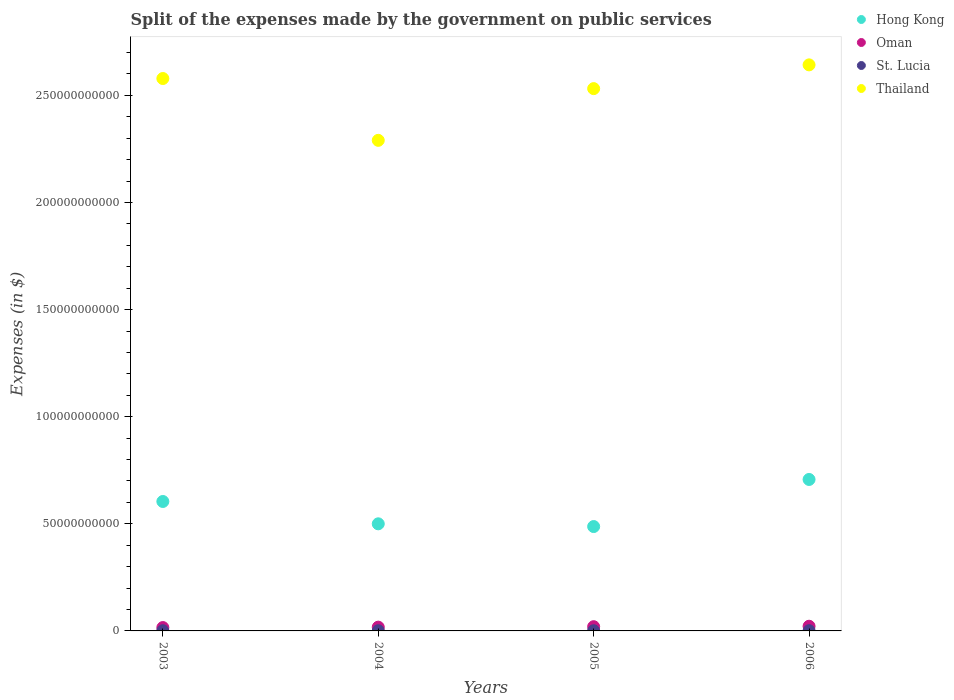What is the expenses made by the government on public services in Oman in 2004?
Provide a short and direct response. 1.77e+09. Across all years, what is the maximum expenses made by the government on public services in Oman?
Offer a very short reply. 2.18e+09. Across all years, what is the minimum expenses made by the government on public services in St. Lucia?
Provide a succinct answer. 8.95e+07. In which year was the expenses made by the government on public services in Thailand maximum?
Give a very brief answer. 2006. In which year was the expenses made by the government on public services in Thailand minimum?
Provide a succinct answer. 2004. What is the total expenses made by the government on public services in Oman in the graph?
Provide a succinct answer. 7.50e+09. What is the difference between the expenses made by the government on public services in Hong Kong in 2005 and that in 2006?
Ensure brevity in your answer.  -2.20e+1. What is the difference between the expenses made by the government on public services in Oman in 2003 and the expenses made by the government on public services in Hong Kong in 2005?
Ensure brevity in your answer.  -4.71e+1. What is the average expenses made by the government on public services in Thailand per year?
Ensure brevity in your answer.  2.51e+11. In the year 2006, what is the difference between the expenses made by the government on public services in St. Lucia and expenses made by the government on public services in Thailand?
Keep it short and to the point. -2.64e+11. In how many years, is the expenses made by the government on public services in Hong Kong greater than 230000000000 $?
Offer a very short reply. 0. What is the ratio of the expenses made by the government on public services in Thailand in 2003 to that in 2006?
Your answer should be very brief. 0.98. Is the expenses made by the government on public services in Hong Kong in 2003 less than that in 2006?
Provide a short and direct response. Yes. What is the difference between the highest and the second highest expenses made by the government on public services in Thailand?
Offer a terse response. 6.37e+09. What is the difference between the highest and the lowest expenses made by the government on public services in Hong Kong?
Offer a terse response. 2.20e+1. Is it the case that in every year, the sum of the expenses made by the government on public services in Oman and expenses made by the government on public services in St. Lucia  is greater than the expenses made by the government on public services in Hong Kong?
Provide a succinct answer. No. Does the expenses made by the government on public services in Oman monotonically increase over the years?
Offer a very short reply. Yes. Is the expenses made by the government on public services in Thailand strictly greater than the expenses made by the government on public services in Hong Kong over the years?
Give a very brief answer. Yes. Is the expenses made by the government on public services in Hong Kong strictly less than the expenses made by the government on public services in Oman over the years?
Make the answer very short. No. Are the values on the major ticks of Y-axis written in scientific E-notation?
Offer a very short reply. No. Does the graph contain any zero values?
Give a very brief answer. No. Does the graph contain grids?
Ensure brevity in your answer.  No. Where does the legend appear in the graph?
Your answer should be compact. Top right. How are the legend labels stacked?
Your answer should be compact. Vertical. What is the title of the graph?
Your answer should be compact. Split of the expenses made by the government on public services. What is the label or title of the X-axis?
Offer a very short reply. Years. What is the label or title of the Y-axis?
Provide a succinct answer. Expenses (in $). What is the Expenses (in $) in Hong Kong in 2003?
Offer a very short reply. 6.04e+1. What is the Expenses (in $) in Oman in 2003?
Provide a succinct answer. 1.57e+09. What is the Expenses (in $) in St. Lucia in 2003?
Give a very brief answer. 8.95e+07. What is the Expenses (in $) of Thailand in 2003?
Offer a terse response. 2.58e+11. What is the Expenses (in $) in Hong Kong in 2004?
Keep it short and to the point. 5.00e+1. What is the Expenses (in $) of Oman in 2004?
Keep it short and to the point. 1.77e+09. What is the Expenses (in $) in St. Lucia in 2004?
Ensure brevity in your answer.  9.55e+07. What is the Expenses (in $) in Thailand in 2004?
Make the answer very short. 2.29e+11. What is the Expenses (in $) in Hong Kong in 2005?
Give a very brief answer. 4.87e+1. What is the Expenses (in $) of Oman in 2005?
Your answer should be compact. 1.97e+09. What is the Expenses (in $) in St. Lucia in 2005?
Offer a very short reply. 9.10e+07. What is the Expenses (in $) of Thailand in 2005?
Your response must be concise. 2.53e+11. What is the Expenses (in $) in Hong Kong in 2006?
Keep it short and to the point. 7.07e+1. What is the Expenses (in $) of Oman in 2006?
Your answer should be compact. 2.18e+09. What is the Expenses (in $) in St. Lucia in 2006?
Ensure brevity in your answer.  1.04e+08. What is the Expenses (in $) in Thailand in 2006?
Your response must be concise. 2.64e+11. Across all years, what is the maximum Expenses (in $) of Hong Kong?
Offer a terse response. 7.07e+1. Across all years, what is the maximum Expenses (in $) in Oman?
Offer a very short reply. 2.18e+09. Across all years, what is the maximum Expenses (in $) in St. Lucia?
Provide a succinct answer. 1.04e+08. Across all years, what is the maximum Expenses (in $) in Thailand?
Ensure brevity in your answer.  2.64e+11. Across all years, what is the minimum Expenses (in $) of Hong Kong?
Provide a succinct answer. 4.87e+1. Across all years, what is the minimum Expenses (in $) in Oman?
Provide a short and direct response. 1.57e+09. Across all years, what is the minimum Expenses (in $) in St. Lucia?
Your response must be concise. 8.95e+07. Across all years, what is the minimum Expenses (in $) in Thailand?
Your response must be concise. 2.29e+11. What is the total Expenses (in $) of Hong Kong in the graph?
Provide a short and direct response. 2.30e+11. What is the total Expenses (in $) in Oman in the graph?
Your response must be concise. 7.50e+09. What is the total Expenses (in $) of St. Lucia in the graph?
Your answer should be very brief. 3.80e+08. What is the total Expenses (in $) of Thailand in the graph?
Make the answer very short. 1.00e+12. What is the difference between the Expenses (in $) of Hong Kong in 2003 and that in 2004?
Keep it short and to the point. 1.04e+1. What is the difference between the Expenses (in $) in Oman in 2003 and that in 2004?
Your answer should be very brief. -1.93e+08. What is the difference between the Expenses (in $) in St. Lucia in 2003 and that in 2004?
Give a very brief answer. -6.00e+06. What is the difference between the Expenses (in $) in Thailand in 2003 and that in 2004?
Give a very brief answer. 2.89e+1. What is the difference between the Expenses (in $) of Hong Kong in 2003 and that in 2005?
Your answer should be compact. 1.17e+1. What is the difference between the Expenses (in $) in Oman in 2003 and that in 2005?
Offer a terse response. -3.99e+08. What is the difference between the Expenses (in $) in St. Lucia in 2003 and that in 2005?
Your response must be concise. -1.50e+06. What is the difference between the Expenses (in $) in Thailand in 2003 and that in 2005?
Provide a short and direct response. 4.71e+09. What is the difference between the Expenses (in $) of Hong Kong in 2003 and that in 2006?
Provide a succinct answer. -1.03e+1. What is the difference between the Expenses (in $) in Oman in 2003 and that in 2006?
Your response must be concise. -6.12e+08. What is the difference between the Expenses (in $) of St. Lucia in 2003 and that in 2006?
Your answer should be very brief. -1.48e+07. What is the difference between the Expenses (in $) in Thailand in 2003 and that in 2006?
Your answer should be compact. -6.37e+09. What is the difference between the Expenses (in $) in Hong Kong in 2004 and that in 2005?
Make the answer very short. 1.28e+09. What is the difference between the Expenses (in $) in Oman in 2004 and that in 2005?
Provide a succinct answer. -2.07e+08. What is the difference between the Expenses (in $) of St. Lucia in 2004 and that in 2005?
Make the answer very short. 4.50e+06. What is the difference between the Expenses (in $) of Thailand in 2004 and that in 2005?
Ensure brevity in your answer.  -2.41e+1. What is the difference between the Expenses (in $) in Hong Kong in 2004 and that in 2006?
Give a very brief answer. -2.07e+1. What is the difference between the Expenses (in $) in Oman in 2004 and that in 2006?
Your answer should be compact. -4.19e+08. What is the difference between the Expenses (in $) in St. Lucia in 2004 and that in 2006?
Offer a terse response. -8.80e+06. What is the difference between the Expenses (in $) of Thailand in 2004 and that in 2006?
Provide a succinct answer. -3.52e+1. What is the difference between the Expenses (in $) in Hong Kong in 2005 and that in 2006?
Your answer should be very brief. -2.20e+1. What is the difference between the Expenses (in $) in Oman in 2005 and that in 2006?
Your answer should be compact. -2.12e+08. What is the difference between the Expenses (in $) in St. Lucia in 2005 and that in 2006?
Keep it short and to the point. -1.33e+07. What is the difference between the Expenses (in $) of Thailand in 2005 and that in 2006?
Your answer should be compact. -1.11e+1. What is the difference between the Expenses (in $) in Hong Kong in 2003 and the Expenses (in $) in Oman in 2004?
Give a very brief answer. 5.87e+1. What is the difference between the Expenses (in $) in Hong Kong in 2003 and the Expenses (in $) in St. Lucia in 2004?
Offer a very short reply. 6.03e+1. What is the difference between the Expenses (in $) in Hong Kong in 2003 and the Expenses (in $) in Thailand in 2004?
Your response must be concise. -1.69e+11. What is the difference between the Expenses (in $) in Oman in 2003 and the Expenses (in $) in St. Lucia in 2004?
Provide a succinct answer. 1.48e+09. What is the difference between the Expenses (in $) in Oman in 2003 and the Expenses (in $) in Thailand in 2004?
Offer a very short reply. -2.27e+11. What is the difference between the Expenses (in $) in St. Lucia in 2003 and the Expenses (in $) in Thailand in 2004?
Provide a succinct answer. -2.29e+11. What is the difference between the Expenses (in $) in Hong Kong in 2003 and the Expenses (in $) in Oman in 2005?
Offer a very short reply. 5.84e+1. What is the difference between the Expenses (in $) in Hong Kong in 2003 and the Expenses (in $) in St. Lucia in 2005?
Your response must be concise. 6.03e+1. What is the difference between the Expenses (in $) in Hong Kong in 2003 and the Expenses (in $) in Thailand in 2005?
Provide a short and direct response. -1.93e+11. What is the difference between the Expenses (in $) in Oman in 2003 and the Expenses (in $) in St. Lucia in 2005?
Make the answer very short. 1.48e+09. What is the difference between the Expenses (in $) of Oman in 2003 and the Expenses (in $) of Thailand in 2005?
Your response must be concise. -2.52e+11. What is the difference between the Expenses (in $) in St. Lucia in 2003 and the Expenses (in $) in Thailand in 2005?
Make the answer very short. -2.53e+11. What is the difference between the Expenses (in $) of Hong Kong in 2003 and the Expenses (in $) of Oman in 2006?
Make the answer very short. 5.82e+1. What is the difference between the Expenses (in $) of Hong Kong in 2003 and the Expenses (in $) of St. Lucia in 2006?
Give a very brief answer. 6.03e+1. What is the difference between the Expenses (in $) in Hong Kong in 2003 and the Expenses (in $) in Thailand in 2006?
Your answer should be very brief. -2.04e+11. What is the difference between the Expenses (in $) in Oman in 2003 and the Expenses (in $) in St. Lucia in 2006?
Offer a terse response. 1.47e+09. What is the difference between the Expenses (in $) of Oman in 2003 and the Expenses (in $) of Thailand in 2006?
Your response must be concise. -2.63e+11. What is the difference between the Expenses (in $) in St. Lucia in 2003 and the Expenses (in $) in Thailand in 2006?
Offer a very short reply. -2.64e+11. What is the difference between the Expenses (in $) in Hong Kong in 2004 and the Expenses (in $) in Oman in 2005?
Your response must be concise. 4.80e+1. What is the difference between the Expenses (in $) of Hong Kong in 2004 and the Expenses (in $) of St. Lucia in 2005?
Offer a terse response. 4.99e+1. What is the difference between the Expenses (in $) in Hong Kong in 2004 and the Expenses (in $) in Thailand in 2005?
Offer a terse response. -2.03e+11. What is the difference between the Expenses (in $) in Oman in 2004 and the Expenses (in $) in St. Lucia in 2005?
Provide a succinct answer. 1.67e+09. What is the difference between the Expenses (in $) in Oman in 2004 and the Expenses (in $) in Thailand in 2005?
Keep it short and to the point. -2.51e+11. What is the difference between the Expenses (in $) in St. Lucia in 2004 and the Expenses (in $) in Thailand in 2005?
Your answer should be compact. -2.53e+11. What is the difference between the Expenses (in $) of Hong Kong in 2004 and the Expenses (in $) of Oman in 2006?
Your answer should be compact. 4.78e+1. What is the difference between the Expenses (in $) of Hong Kong in 2004 and the Expenses (in $) of St. Lucia in 2006?
Offer a very short reply. 4.99e+1. What is the difference between the Expenses (in $) of Hong Kong in 2004 and the Expenses (in $) of Thailand in 2006?
Provide a succinct answer. -2.14e+11. What is the difference between the Expenses (in $) in Oman in 2004 and the Expenses (in $) in St. Lucia in 2006?
Your response must be concise. 1.66e+09. What is the difference between the Expenses (in $) in Oman in 2004 and the Expenses (in $) in Thailand in 2006?
Provide a short and direct response. -2.62e+11. What is the difference between the Expenses (in $) of St. Lucia in 2004 and the Expenses (in $) of Thailand in 2006?
Provide a succinct answer. -2.64e+11. What is the difference between the Expenses (in $) in Hong Kong in 2005 and the Expenses (in $) in Oman in 2006?
Ensure brevity in your answer.  4.65e+1. What is the difference between the Expenses (in $) in Hong Kong in 2005 and the Expenses (in $) in St. Lucia in 2006?
Give a very brief answer. 4.86e+1. What is the difference between the Expenses (in $) in Hong Kong in 2005 and the Expenses (in $) in Thailand in 2006?
Provide a succinct answer. -2.16e+11. What is the difference between the Expenses (in $) of Oman in 2005 and the Expenses (in $) of St. Lucia in 2006?
Make the answer very short. 1.87e+09. What is the difference between the Expenses (in $) of Oman in 2005 and the Expenses (in $) of Thailand in 2006?
Offer a terse response. -2.62e+11. What is the difference between the Expenses (in $) in St. Lucia in 2005 and the Expenses (in $) in Thailand in 2006?
Your answer should be compact. -2.64e+11. What is the average Expenses (in $) in Hong Kong per year?
Keep it short and to the point. 5.75e+1. What is the average Expenses (in $) of Oman per year?
Ensure brevity in your answer.  1.87e+09. What is the average Expenses (in $) of St. Lucia per year?
Ensure brevity in your answer.  9.51e+07. What is the average Expenses (in $) in Thailand per year?
Ensure brevity in your answer.  2.51e+11. In the year 2003, what is the difference between the Expenses (in $) of Hong Kong and Expenses (in $) of Oman?
Keep it short and to the point. 5.88e+1. In the year 2003, what is the difference between the Expenses (in $) of Hong Kong and Expenses (in $) of St. Lucia?
Your answer should be very brief. 6.03e+1. In the year 2003, what is the difference between the Expenses (in $) of Hong Kong and Expenses (in $) of Thailand?
Keep it short and to the point. -1.97e+11. In the year 2003, what is the difference between the Expenses (in $) of Oman and Expenses (in $) of St. Lucia?
Your response must be concise. 1.48e+09. In the year 2003, what is the difference between the Expenses (in $) of Oman and Expenses (in $) of Thailand?
Your response must be concise. -2.56e+11. In the year 2003, what is the difference between the Expenses (in $) in St. Lucia and Expenses (in $) in Thailand?
Make the answer very short. -2.58e+11. In the year 2004, what is the difference between the Expenses (in $) of Hong Kong and Expenses (in $) of Oman?
Offer a terse response. 4.82e+1. In the year 2004, what is the difference between the Expenses (in $) in Hong Kong and Expenses (in $) in St. Lucia?
Your answer should be very brief. 4.99e+1. In the year 2004, what is the difference between the Expenses (in $) in Hong Kong and Expenses (in $) in Thailand?
Offer a very short reply. -1.79e+11. In the year 2004, what is the difference between the Expenses (in $) in Oman and Expenses (in $) in St. Lucia?
Your answer should be compact. 1.67e+09. In the year 2004, what is the difference between the Expenses (in $) in Oman and Expenses (in $) in Thailand?
Your answer should be compact. -2.27e+11. In the year 2004, what is the difference between the Expenses (in $) in St. Lucia and Expenses (in $) in Thailand?
Offer a terse response. -2.29e+11. In the year 2005, what is the difference between the Expenses (in $) in Hong Kong and Expenses (in $) in Oman?
Provide a short and direct response. 4.67e+1. In the year 2005, what is the difference between the Expenses (in $) of Hong Kong and Expenses (in $) of St. Lucia?
Offer a terse response. 4.86e+1. In the year 2005, what is the difference between the Expenses (in $) of Hong Kong and Expenses (in $) of Thailand?
Ensure brevity in your answer.  -2.04e+11. In the year 2005, what is the difference between the Expenses (in $) in Oman and Expenses (in $) in St. Lucia?
Offer a terse response. 1.88e+09. In the year 2005, what is the difference between the Expenses (in $) in Oman and Expenses (in $) in Thailand?
Keep it short and to the point. -2.51e+11. In the year 2005, what is the difference between the Expenses (in $) of St. Lucia and Expenses (in $) of Thailand?
Offer a terse response. -2.53e+11. In the year 2006, what is the difference between the Expenses (in $) in Hong Kong and Expenses (in $) in Oman?
Your answer should be compact. 6.85e+1. In the year 2006, what is the difference between the Expenses (in $) in Hong Kong and Expenses (in $) in St. Lucia?
Provide a short and direct response. 7.06e+1. In the year 2006, what is the difference between the Expenses (in $) in Hong Kong and Expenses (in $) in Thailand?
Your answer should be compact. -1.94e+11. In the year 2006, what is the difference between the Expenses (in $) of Oman and Expenses (in $) of St. Lucia?
Keep it short and to the point. 2.08e+09. In the year 2006, what is the difference between the Expenses (in $) of Oman and Expenses (in $) of Thailand?
Provide a short and direct response. -2.62e+11. In the year 2006, what is the difference between the Expenses (in $) of St. Lucia and Expenses (in $) of Thailand?
Keep it short and to the point. -2.64e+11. What is the ratio of the Expenses (in $) of Hong Kong in 2003 to that in 2004?
Provide a succinct answer. 1.21. What is the ratio of the Expenses (in $) of Oman in 2003 to that in 2004?
Your response must be concise. 0.89. What is the ratio of the Expenses (in $) of St. Lucia in 2003 to that in 2004?
Your answer should be compact. 0.94. What is the ratio of the Expenses (in $) of Thailand in 2003 to that in 2004?
Provide a succinct answer. 1.13. What is the ratio of the Expenses (in $) in Hong Kong in 2003 to that in 2005?
Provide a succinct answer. 1.24. What is the ratio of the Expenses (in $) in Oman in 2003 to that in 2005?
Your answer should be compact. 0.8. What is the ratio of the Expenses (in $) of St. Lucia in 2003 to that in 2005?
Make the answer very short. 0.98. What is the ratio of the Expenses (in $) in Thailand in 2003 to that in 2005?
Your answer should be very brief. 1.02. What is the ratio of the Expenses (in $) in Hong Kong in 2003 to that in 2006?
Give a very brief answer. 0.85. What is the ratio of the Expenses (in $) in Oman in 2003 to that in 2006?
Provide a succinct answer. 0.72. What is the ratio of the Expenses (in $) in St. Lucia in 2003 to that in 2006?
Keep it short and to the point. 0.86. What is the ratio of the Expenses (in $) of Thailand in 2003 to that in 2006?
Provide a short and direct response. 0.98. What is the ratio of the Expenses (in $) of Hong Kong in 2004 to that in 2005?
Make the answer very short. 1.03. What is the ratio of the Expenses (in $) in Oman in 2004 to that in 2005?
Keep it short and to the point. 0.9. What is the ratio of the Expenses (in $) in St. Lucia in 2004 to that in 2005?
Make the answer very short. 1.05. What is the ratio of the Expenses (in $) of Thailand in 2004 to that in 2005?
Keep it short and to the point. 0.9. What is the ratio of the Expenses (in $) in Hong Kong in 2004 to that in 2006?
Your answer should be very brief. 0.71. What is the ratio of the Expenses (in $) in Oman in 2004 to that in 2006?
Make the answer very short. 0.81. What is the ratio of the Expenses (in $) in St. Lucia in 2004 to that in 2006?
Offer a terse response. 0.92. What is the ratio of the Expenses (in $) of Thailand in 2004 to that in 2006?
Keep it short and to the point. 0.87. What is the ratio of the Expenses (in $) in Hong Kong in 2005 to that in 2006?
Provide a succinct answer. 0.69. What is the ratio of the Expenses (in $) in Oman in 2005 to that in 2006?
Offer a very short reply. 0.9. What is the ratio of the Expenses (in $) in St. Lucia in 2005 to that in 2006?
Your answer should be very brief. 0.87. What is the ratio of the Expenses (in $) of Thailand in 2005 to that in 2006?
Offer a terse response. 0.96. What is the difference between the highest and the second highest Expenses (in $) in Hong Kong?
Keep it short and to the point. 1.03e+1. What is the difference between the highest and the second highest Expenses (in $) in Oman?
Your answer should be compact. 2.12e+08. What is the difference between the highest and the second highest Expenses (in $) of St. Lucia?
Give a very brief answer. 8.80e+06. What is the difference between the highest and the second highest Expenses (in $) in Thailand?
Ensure brevity in your answer.  6.37e+09. What is the difference between the highest and the lowest Expenses (in $) in Hong Kong?
Ensure brevity in your answer.  2.20e+1. What is the difference between the highest and the lowest Expenses (in $) of Oman?
Your answer should be very brief. 6.12e+08. What is the difference between the highest and the lowest Expenses (in $) of St. Lucia?
Keep it short and to the point. 1.48e+07. What is the difference between the highest and the lowest Expenses (in $) in Thailand?
Make the answer very short. 3.52e+1. 